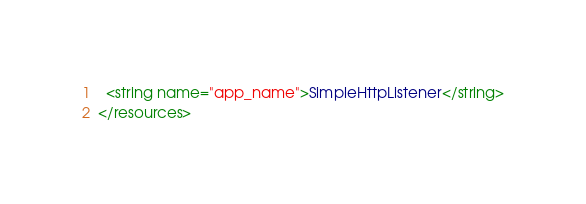Convert code to text. <code><loc_0><loc_0><loc_500><loc_500><_XML_>  <string name="app_name">SimpleHttpListener</string>
</resources></code> 